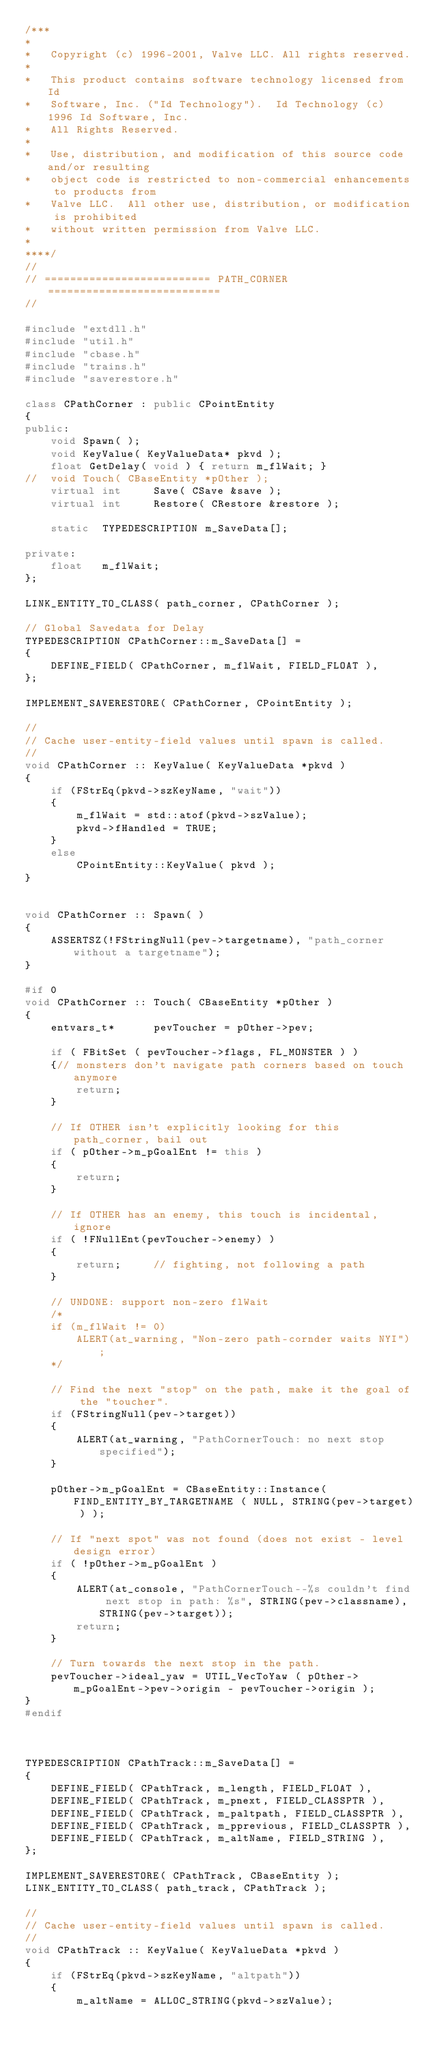Convert code to text. <code><loc_0><loc_0><loc_500><loc_500><_C++_>/***
*
*	Copyright (c) 1996-2001, Valve LLC. All rights reserved.
*	
*	This product contains software technology licensed from Id 
*	Software, Inc. ("Id Technology").  Id Technology (c) 1996 Id Software, Inc. 
*	All Rights Reserved.
*
*   Use, distribution, and modification of this source code and/or resulting
*   object code is restricted to non-commercial enhancements to products from
*   Valve LLC.  All other use, distribution, or modification is prohibited
*   without written permission from Valve LLC.
*
****/
//
// ========================== PATH_CORNER ===========================
//

#include "extdll.h"
#include "util.h"
#include "cbase.h"
#include "trains.h"
#include "saverestore.h"

class CPathCorner : public CPointEntity
{
public:
	void Spawn( );
	void KeyValue( KeyValueData* pkvd );
	float GetDelay( void ) { return m_flWait; }
//	void Touch( CBaseEntity *pOther );
	virtual int		Save( CSave &save );
	virtual int		Restore( CRestore &restore );
	
	static	TYPEDESCRIPTION m_SaveData[];

private:
	float	m_flWait;
};

LINK_ENTITY_TO_CLASS( path_corner, CPathCorner );

// Global Savedata for Delay
TYPEDESCRIPTION	CPathCorner::m_SaveData[] = 
{
	DEFINE_FIELD( CPathCorner, m_flWait, FIELD_FLOAT ),
};

IMPLEMENT_SAVERESTORE( CPathCorner, CPointEntity );

//
// Cache user-entity-field values until spawn is called.
//
void CPathCorner :: KeyValue( KeyValueData *pkvd )
{
	if (FStrEq(pkvd->szKeyName, "wait"))
	{
		m_flWait = std::atof(pkvd->szValue);
		pkvd->fHandled = TRUE;
	}
	else 
		CPointEntity::KeyValue( pkvd );
}


void CPathCorner :: Spawn( )
{
	ASSERTSZ(!FStringNull(pev->targetname), "path_corner without a targetname");
}

#if 0
void CPathCorner :: Touch( CBaseEntity *pOther )
{
	entvars_t*		pevToucher = pOther->pev;
		
	if ( FBitSet ( pevToucher->flags, FL_MONSTER ) )
	{// monsters don't navigate path corners based on touch anymore
		return;
	}

	// If OTHER isn't explicitly looking for this path_corner, bail out
	if ( pOther->m_pGoalEnt != this )
	{
		return;
	}

	// If OTHER has an enemy, this touch is incidental, ignore
	if ( !FNullEnt(pevToucher->enemy) )
	{
		return;		// fighting, not following a path
	}
	
	// UNDONE: support non-zero flWait
	/*
	if (m_flWait != 0)
		ALERT(at_warning, "Non-zero path-cornder waits NYI");
	*/

	// Find the next "stop" on the path, make it the goal of the "toucher".
	if (FStringNull(pev->target))
	{
		ALERT(at_warning, "PathCornerTouch: no next stop specified");
	}

	pOther->m_pGoalEnt = CBaseEntity::Instance( FIND_ENTITY_BY_TARGETNAME ( NULL, STRING(pev->target) ) );

	// If "next spot" was not found (does not exist - level design error)
	if ( !pOther->m_pGoalEnt )
	{
		ALERT(at_console, "PathCornerTouch--%s couldn't find next stop in path: %s", STRING(pev->classname), STRING(pev->target));
		return;
	}

	// Turn towards the next stop in the path.
	pevToucher->ideal_yaw = UTIL_VecToYaw ( pOther->m_pGoalEnt->pev->origin - pevToucher->origin );
}
#endif



TYPEDESCRIPTION	CPathTrack::m_SaveData[] = 
{
	DEFINE_FIELD( CPathTrack, m_length, FIELD_FLOAT ),
	DEFINE_FIELD( CPathTrack, m_pnext, FIELD_CLASSPTR ),
	DEFINE_FIELD( CPathTrack, m_paltpath, FIELD_CLASSPTR ),
	DEFINE_FIELD( CPathTrack, m_pprevious, FIELD_CLASSPTR ),
	DEFINE_FIELD( CPathTrack, m_altName, FIELD_STRING ),
};

IMPLEMENT_SAVERESTORE( CPathTrack, CBaseEntity );
LINK_ENTITY_TO_CLASS( path_track, CPathTrack );

//
// Cache user-entity-field values until spawn is called.
//
void CPathTrack :: KeyValue( KeyValueData *pkvd )
{
	if (FStrEq(pkvd->szKeyName, "altpath"))
	{
		m_altName = ALLOC_STRING(pkvd->szValue);</code> 